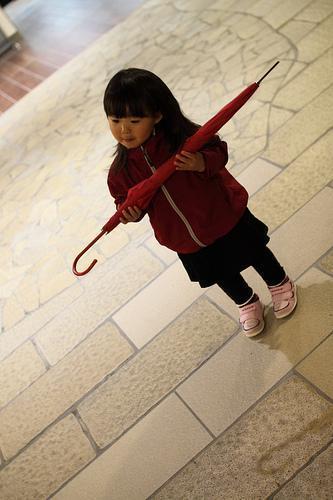How many umbrellas?
Give a very brief answer. 1. 